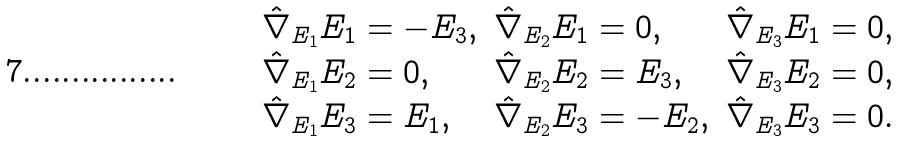<formula> <loc_0><loc_0><loc_500><loc_500>\begin{array} { l l l } \hat { \nabla } _ { E _ { 1 } } E _ { 1 } = - E _ { 3 } , & \hat { \nabla } _ { E _ { 2 } } E _ { 1 } = 0 , & \hat { \nabla } _ { E _ { 3 } } E _ { 1 } = 0 , \\ \hat { \nabla } _ { E _ { 1 } } E _ { 2 } = 0 , & \hat { \nabla } _ { E _ { 2 } } E _ { 2 } = E _ { 3 } , & \hat { \nabla } _ { E _ { 3 } } E _ { 2 } = 0 , \\ \hat { \nabla } _ { E _ { 1 } } E _ { 3 } = E _ { 1 } , & \hat { \nabla } _ { E _ { 2 } } E _ { 3 } = - E _ { 2 } , & \hat { \nabla } _ { E _ { 3 } } E _ { 3 } = 0 . \end{array}</formula> 